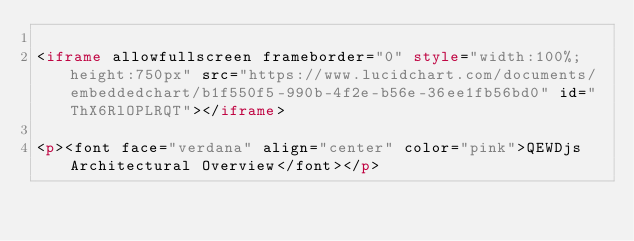<code> <loc_0><loc_0><loc_500><loc_500><_HTML_>
<iframe allowfullscreen frameborder="0" style="width:100%; height:750px" src="https://www.lucidchart.com/documents/embeddedchart/b1f550f5-990b-4f2e-b56e-36ee1fb56bd0" id="ThX6RlOPLRQT"></iframe>

<p><font face="verdana" align="center" color="pink">QEWDjs Architectural Overview</font></p>
</code> 